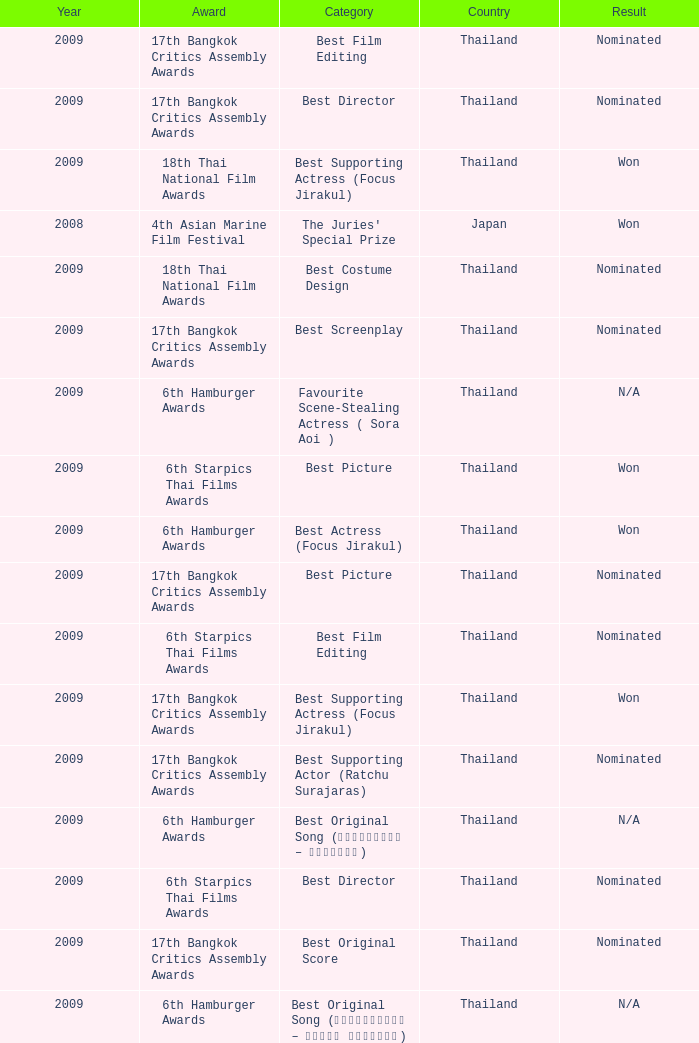Which Country has a Result of nominated, an Award of 17th bangkok critics assembly awards, and a Category of best screenplay? Thailand. 